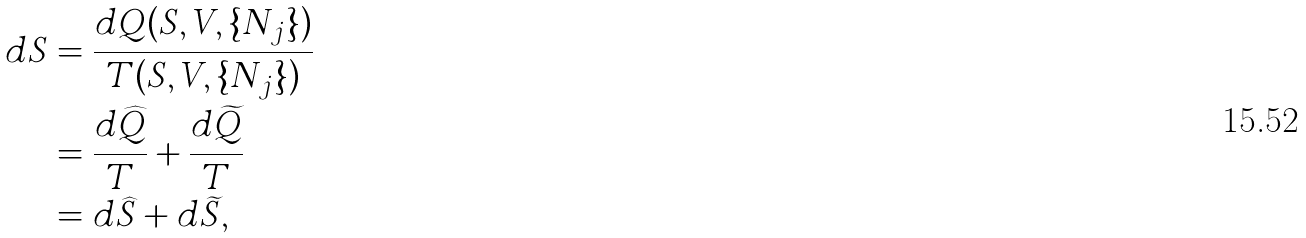Convert formula to latex. <formula><loc_0><loc_0><loc_500><loc_500>d S & = \frac { d Q ( S , V , \{ N _ { j } \} ) } { T ( S , V , \{ N _ { j } \} ) } \\ & = \frac { d \widehat { Q } } { T } + \frac { d \widetilde { Q } } { T } \\ & = d \widehat { S } + d \widetilde { S } ,</formula> 